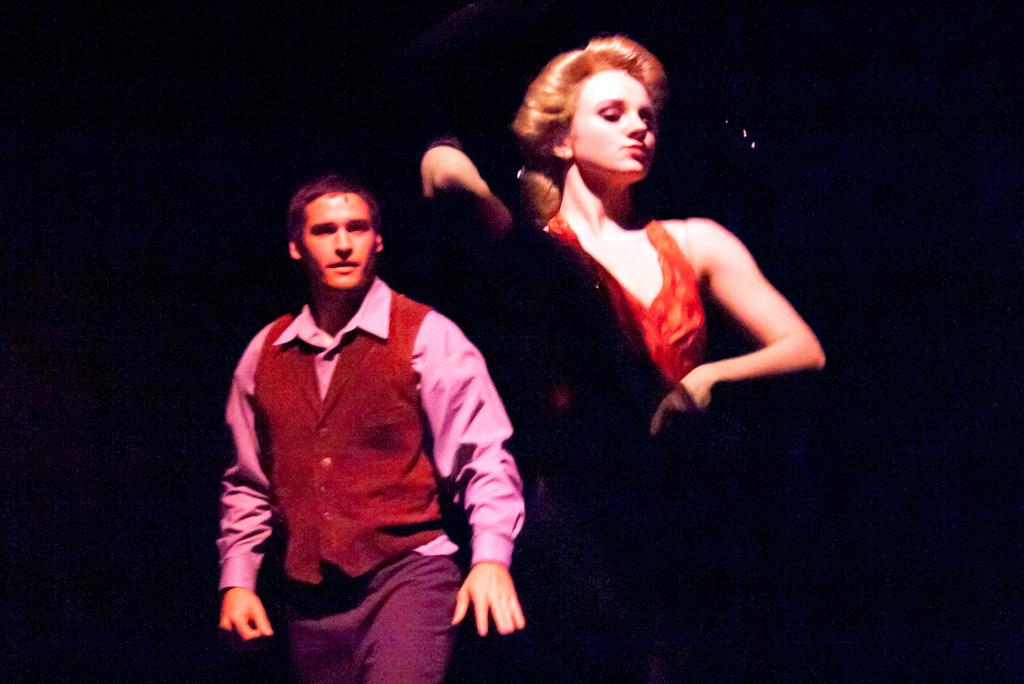How many people are in the image? There are two people in the image. What can be observed about the clothing of the people in the image? The people are wearing different color dresses. What is the color of the background in the image? The background of the image is black. Can you see any planes in the image? There are no planes visible in the image. What type of toe is visible on the people in the image? There is no toe visible in the image; only the people's dresses are mentioned. 